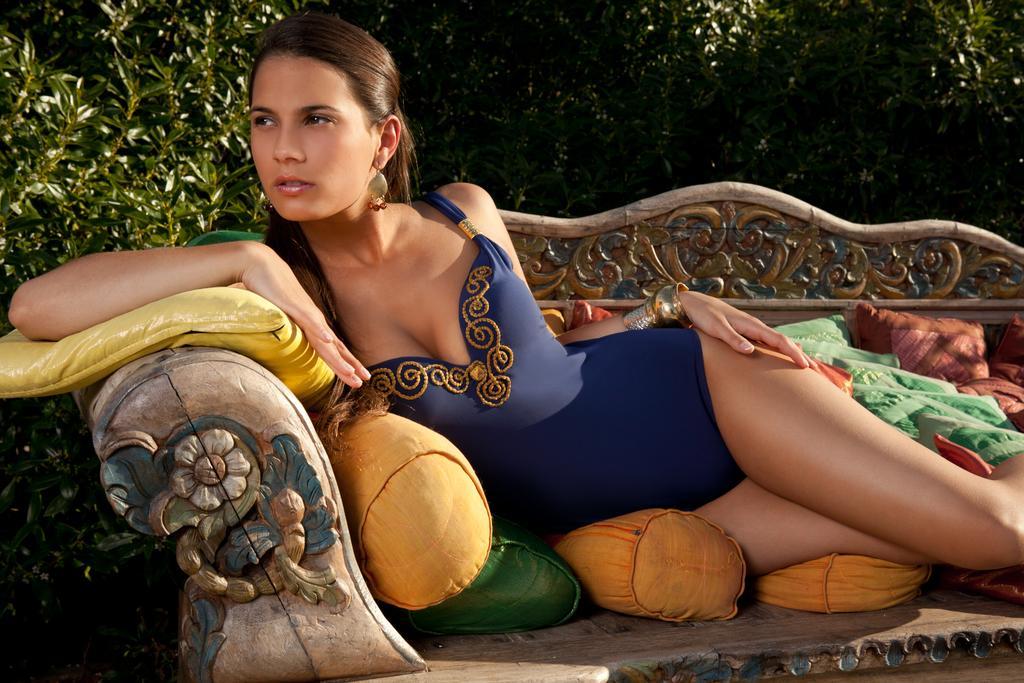How would you summarize this image in a sentence or two? Here I can see a woman wearing a blue color dress, laying on a bench and looking at the left side. On this bench there are few pillows. In the background there are some trees. 